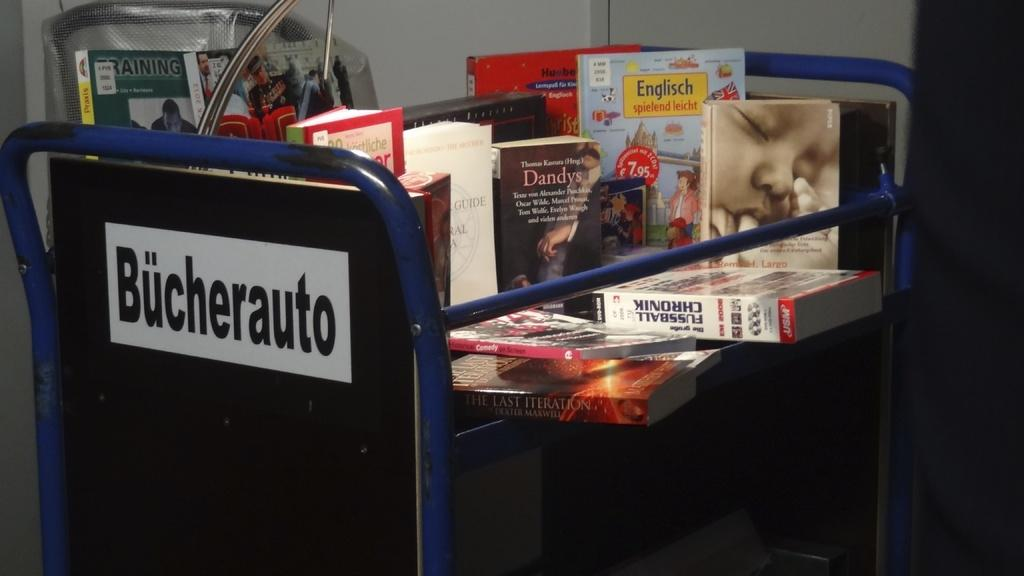<image>
Write a terse but informative summary of the picture. a portable shelf from Bucherauto filled with books 